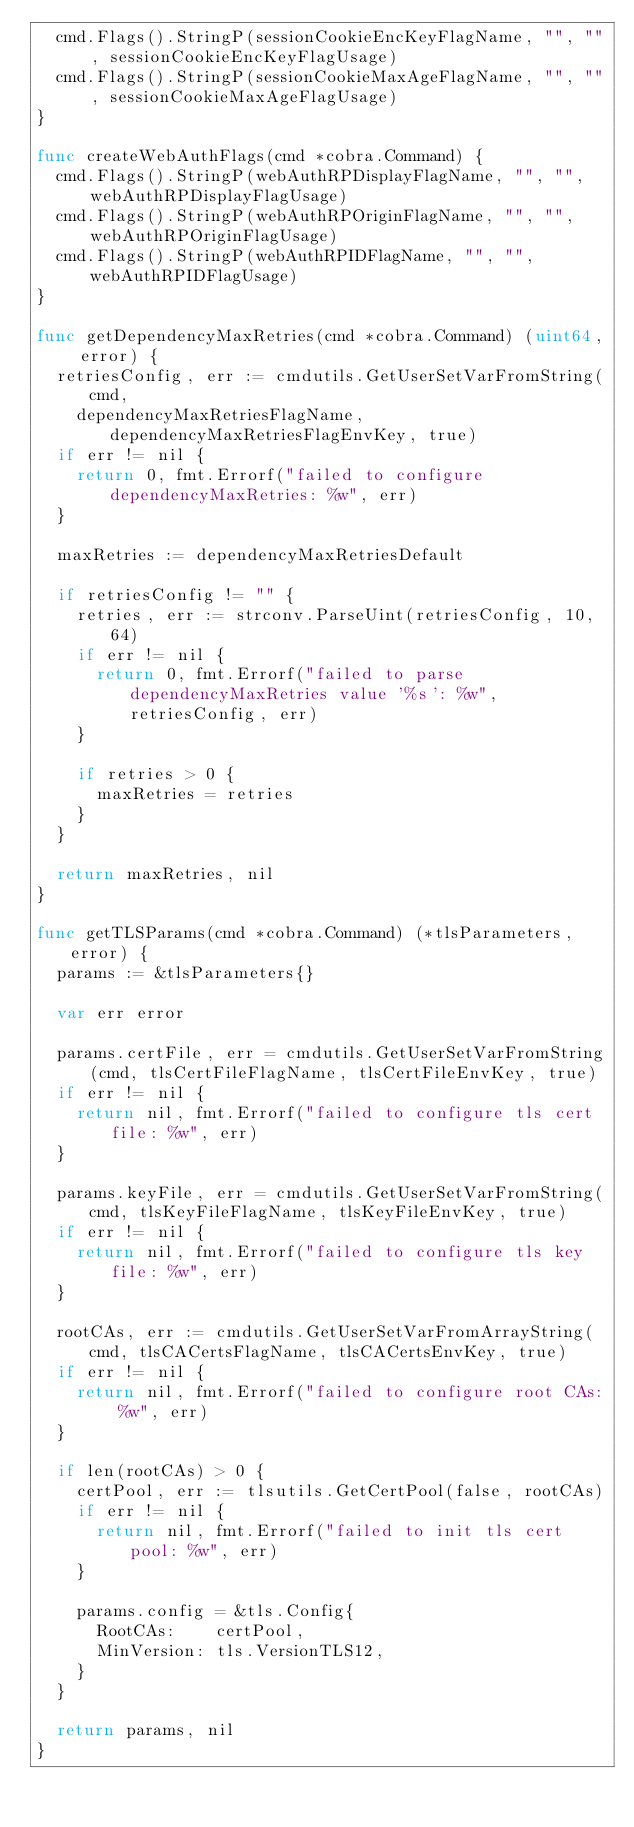Convert code to text. <code><loc_0><loc_0><loc_500><loc_500><_Go_>	cmd.Flags().StringP(sessionCookieEncKeyFlagName, "", "", sessionCookieEncKeyFlagUsage)
	cmd.Flags().StringP(sessionCookieMaxAgeFlagName, "", "", sessionCookieMaxAgeFlagUsage)
}

func createWebAuthFlags(cmd *cobra.Command) {
	cmd.Flags().StringP(webAuthRPDisplayFlagName, "", "", webAuthRPDisplayFlagUsage)
	cmd.Flags().StringP(webAuthRPOriginFlagName, "", "", webAuthRPOriginFlagUsage)
	cmd.Flags().StringP(webAuthRPIDFlagName, "", "", webAuthRPIDFlagUsage)
}

func getDependencyMaxRetries(cmd *cobra.Command) (uint64, error) {
	retriesConfig, err := cmdutils.GetUserSetVarFromString(cmd,
		dependencyMaxRetriesFlagName, dependencyMaxRetriesFlagEnvKey, true)
	if err != nil {
		return 0, fmt.Errorf("failed to configure dependencyMaxRetries: %w", err)
	}

	maxRetries := dependencyMaxRetriesDefault

	if retriesConfig != "" {
		retries, err := strconv.ParseUint(retriesConfig, 10, 64)
		if err != nil {
			return 0, fmt.Errorf("failed to parse dependencyMaxRetries value '%s': %w", retriesConfig, err)
		}

		if retries > 0 {
			maxRetries = retries
		}
	}

	return maxRetries, nil
}

func getTLSParams(cmd *cobra.Command) (*tlsParameters, error) {
	params := &tlsParameters{}

	var err error

	params.certFile, err = cmdutils.GetUserSetVarFromString(cmd, tlsCertFileFlagName, tlsCertFileEnvKey, true)
	if err != nil {
		return nil, fmt.Errorf("failed to configure tls cert file: %w", err)
	}

	params.keyFile, err = cmdutils.GetUserSetVarFromString(cmd, tlsKeyFileFlagName, tlsKeyFileEnvKey, true)
	if err != nil {
		return nil, fmt.Errorf("failed to configure tls key file: %w", err)
	}

	rootCAs, err := cmdutils.GetUserSetVarFromArrayString(cmd, tlsCACertsFlagName, tlsCACertsEnvKey, true)
	if err != nil {
		return nil, fmt.Errorf("failed to configure root CAs: %w", err)
	}

	if len(rootCAs) > 0 {
		certPool, err := tlsutils.GetCertPool(false, rootCAs)
		if err != nil {
			return nil, fmt.Errorf("failed to init tls cert pool: %w", err)
		}

		params.config = &tls.Config{
			RootCAs:    certPool,
			MinVersion: tls.VersionTLS12,
		}
	}

	return params, nil
}
</code> 